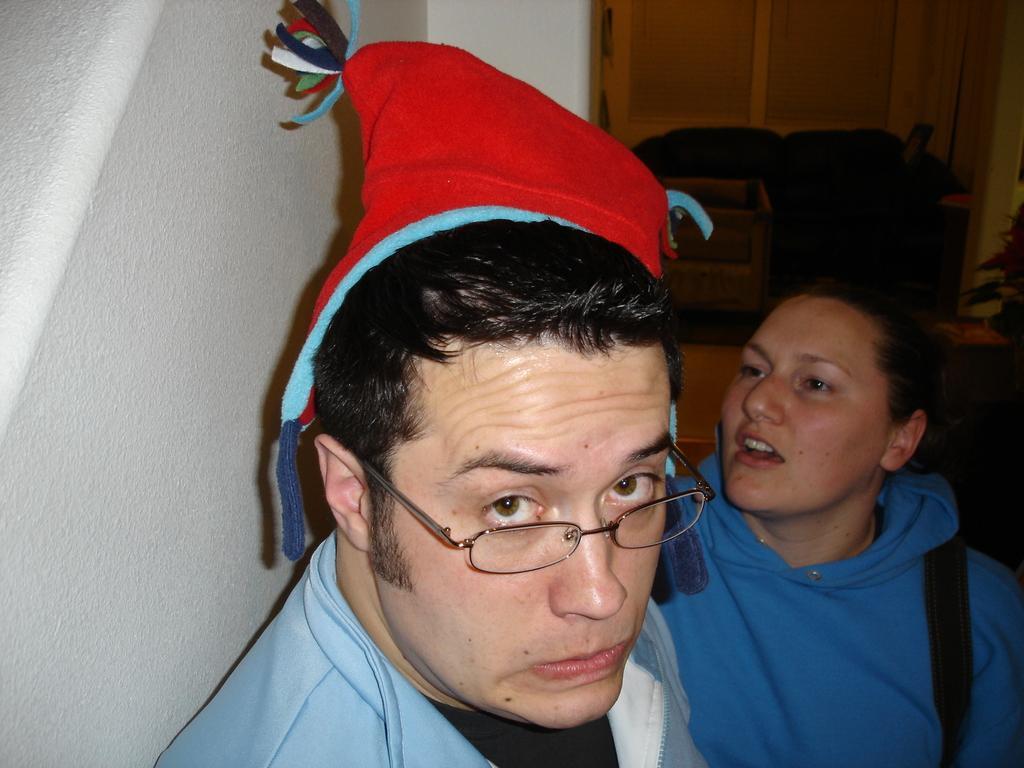In one or two sentences, can you explain what this image depicts? In this image we can see a man and a woman. In that a man is wearing a cap. We can also see a wall, couch, a container and a door. 